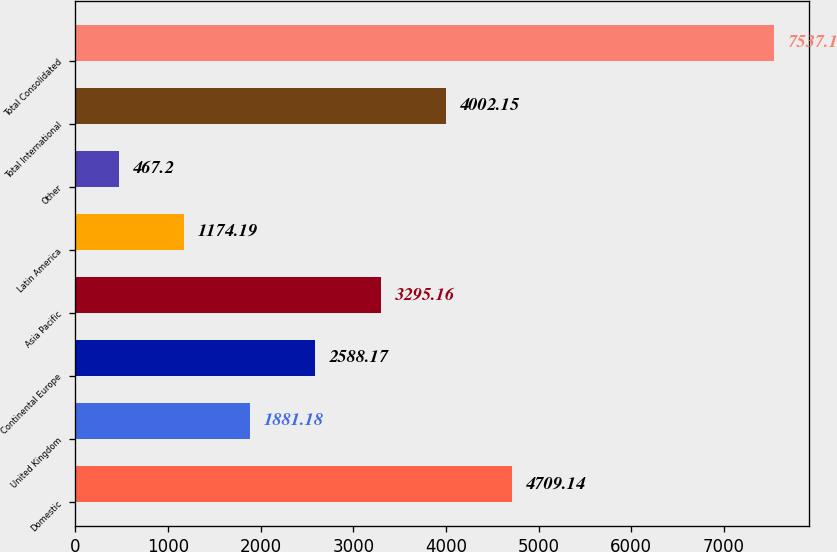Convert chart. <chart><loc_0><loc_0><loc_500><loc_500><bar_chart><fcel>Domestic<fcel>United Kingdom<fcel>Continental Europe<fcel>Asia Pacific<fcel>Latin America<fcel>Other<fcel>Total International<fcel>Total Consolidated<nl><fcel>4709.14<fcel>1881.18<fcel>2588.17<fcel>3295.16<fcel>1174.19<fcel>467.2<fcel>4002.15<fcel>7537.1<nl></chart> 